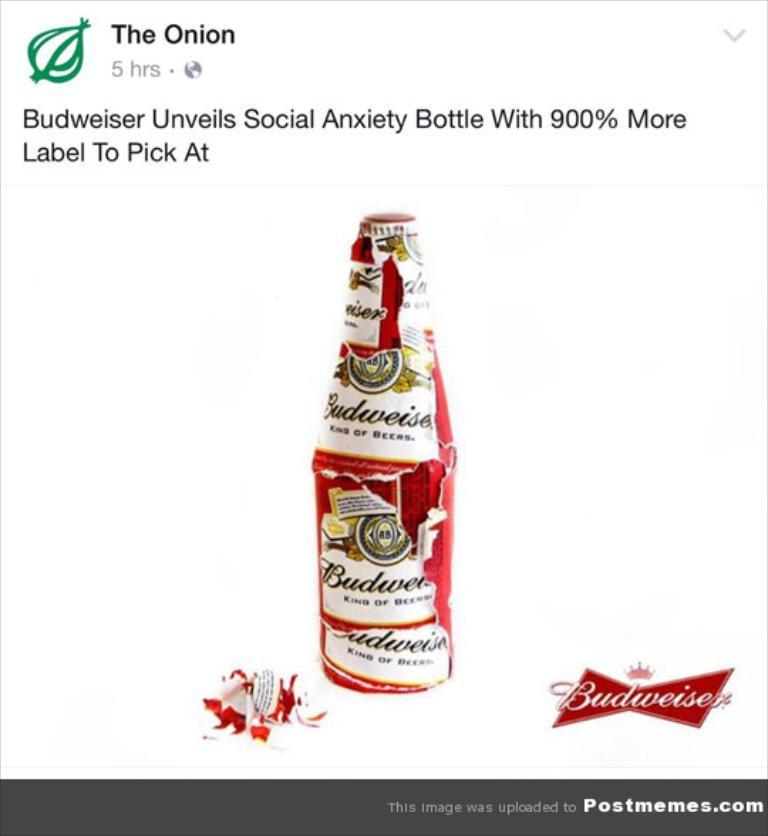<image>
Write a terse but informative summary of the picture. An article about Budweiser from the news source the Onion. 